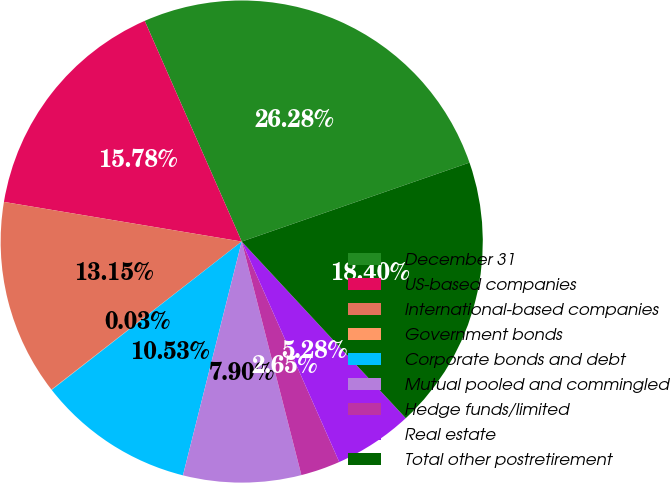<chart> <loc_0><loc_0><loc_500><loc_500><pie_chart><fcel>December 31<fcel>US-based companies<fcel>International-based companies<fcel>Government bonds<fcel>Corporate bonds and debt<fcel>Mutual pooled and commingled<fcel>Hedge funds/limited<fcel>Real estate<fcel>Total other postretirement<nl><fcel>26.28%<fcel>15.78%<fcel>13.15%<fcel>0.03%<fcel>10.53%<fcel>7.9%<fcel>2.65%<fcel>5.28%<fcel>18.4%<nl></chart> 